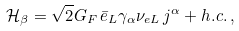Convert formula to latex. <formula><loc_0><loc_0><loc_500><loc_500>\mathcal { H } _ { \beta } = \sqrt { 2 } G _ { F } \, \bar { e } _ { L } \gamma _ { \alpha } \nu _ { e L } \, j ^ { \alpha } + h . c . \, ,</formula> 